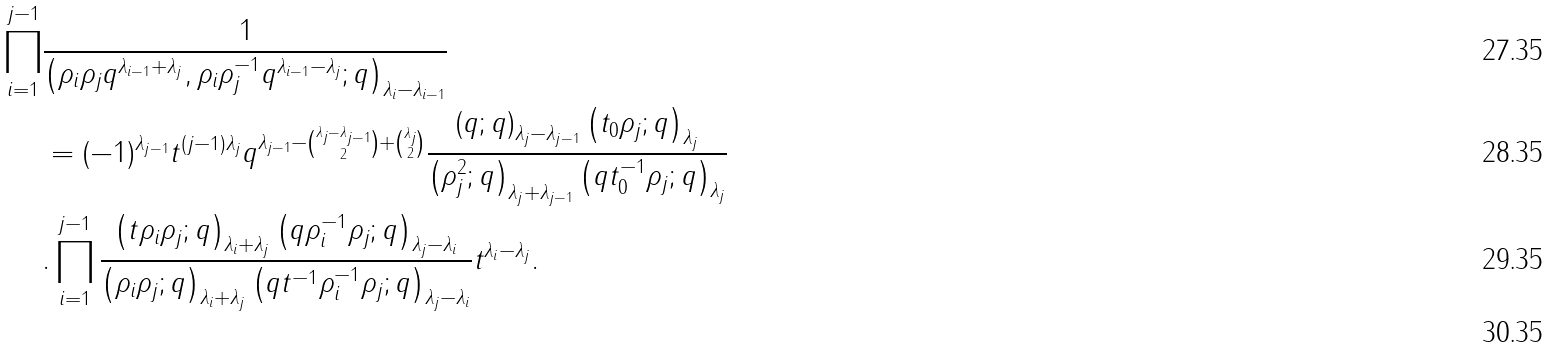Convert formula to latex. <formula><loc_0><loc_0><loc_500><loc_500>\prod _ { i = 1 } ^ { j - 1 } & \frac { 1 } { \left ( \rho _ { i } \rho _ { j } q ^ { \lambda _ { i - 1 } + \lambda _ { j } } , \rho _ { i } \rho _ { j } ^ { - 1 } q ^ { \lambda _ { i - 1 } - \lambda _ { j } } ; q \right ) _ { \lambda _ { i } - \lambda _ { i - 1 } } } \\ & = ( - 1 ) ^ { \lambda _ { j - 1 } } t ^ { ( j - 1 ) \lambda _ { j } } q ^ { \lambda _ { j - 1 } - \binom { \lambda _ { j } - \lambda _ { j - 1 } } { 2 } + \binom { \lambda _ { j } } { 2 } } \frac { \left ( q ; q \right ) _ { \lambda _ { j } - \lambda _ { j - 1 } } \left ( t _ { 0 } \rho _ { j } ; q \right ) _ { \lambda _ { j } } } { \left ( \rho _ { j } ^ { 2 } ; q \right ) _ { \lambda _ { j } + \lambda _ { j - 1 } } \left ( q t _ { 0 } ^ { - 1 } \rho _ { j } ; q \right ) _ { \lambda _ { j } } } \\ & . \prod _ { i = 1 } ^ { j - 1 } \frac { \left ( t \rho _ { i } \rho _ { j } ; q \right ) _ { \lambda _ { i } + \lambda _ { j } } \left ( q \rho _ { i } ^ { - 1 } \rho _ { j } ; q \right ) _ { \lambda _ { j } - \lambda _ { i } } } { \left ( \rho _ { i } \rho _ { j } ; q \right ) _ { \lambda _ { i } + \lambda _ { j } } \left ( q t ^ { - 1 } \rho _ { i } ^ { - 1 } \rho _ { j } ; q \right ) _ { \lambda _ { j } - \lambda _ { i } } } t ^ { \lambda _ { i } - \lambda _ { j } } . \\</formula> 